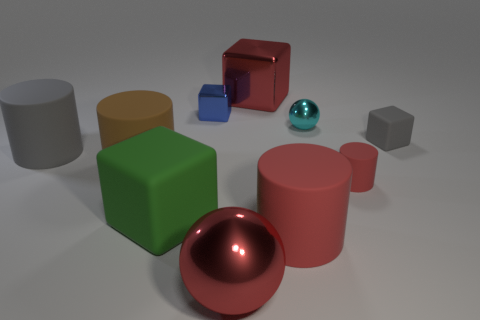There is a red matte object that is the same size as the gray matte cylinder; what shape is it?
Make the answer very short. Cylinder. How many other objects are the same color as the small rubber cylinder?
Provide a short and direct response. 3. There is a rubber object that is right of the gray rubber cylinder and behind the brown object; what is its shape?
Ensure brevity in your answer.  Cube. Are there any large green cubes that are behind the small thing that is left of the ball that is behind the big red sphere?
Offer a terse response. No. What number of other things are there of the same material as the big gray thing
Offer a very short reply. 5. How many yellow metal balls are there?
Provide a succinct answer. 0. How many objects are small gray rubber things or big shiny things that are in front of the gray rubber cylinder?
Offer a very short reply. 2. Is there any other thing that has the same shape as the large red rubber object?
Your answer should be compact. Yes. There is a red shiny object that is in front of the gray matte block; does it have the same size as the tiny red thing?
Keep it short and to the point. No. What number of matte things are either small spheres or cyan cylinders?
Make the answer very short. 0. 